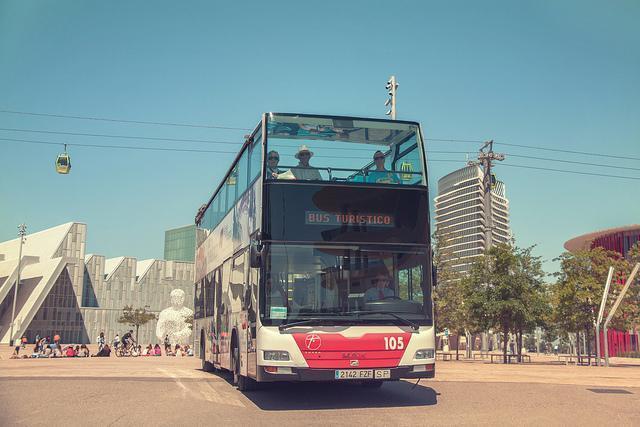Is the statement "The bus is behind the bicycle." accurate regarding the image?
Answer yes or no. No. 